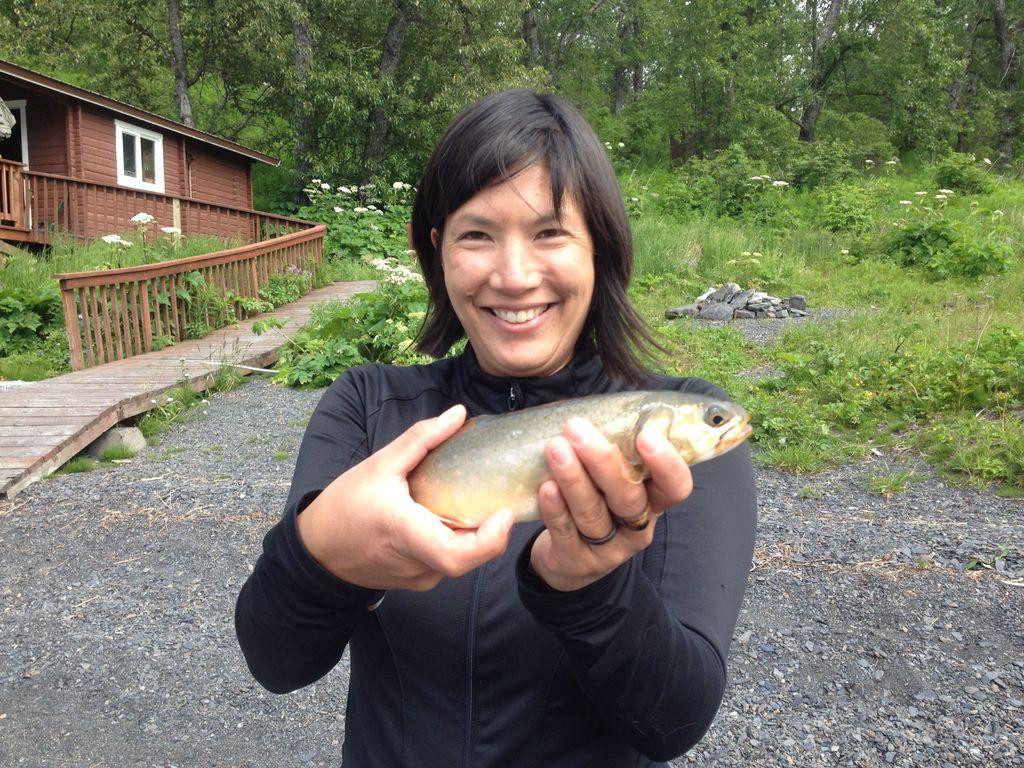Describe this image in one or two sentences. In this picture there is a woman smiling and holding a fish. In the background of the image we can see plants, flowers, grass, house, fence, stones and trees. 